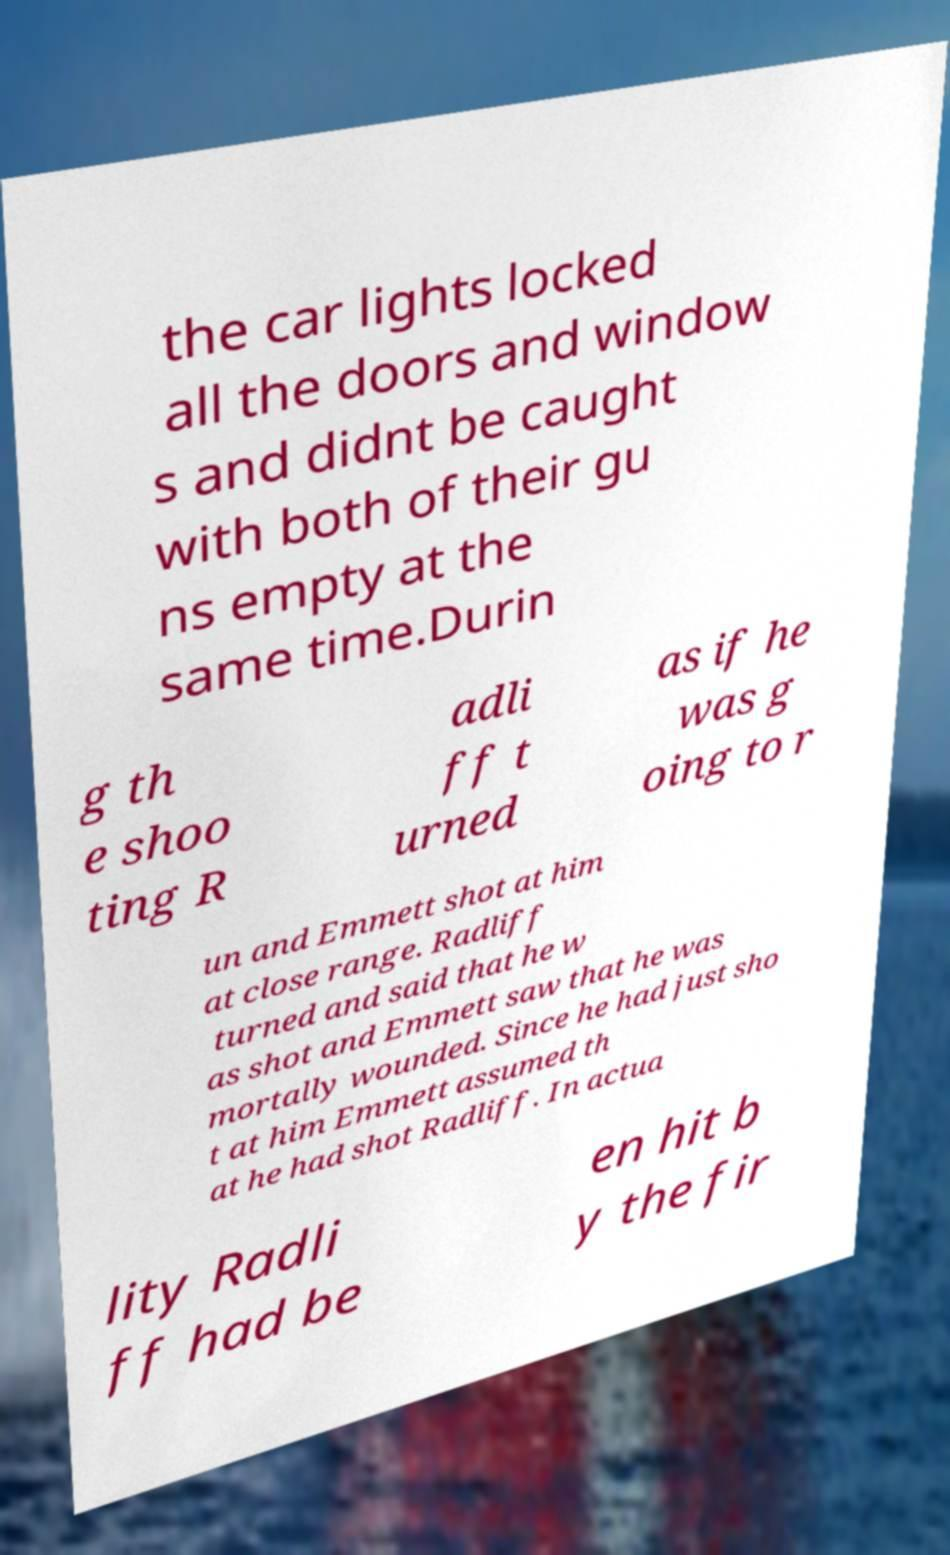For documentation purposes, I need the text within this image transcribed. Could you provide that? the car lights locked all the doors and window s and didnt be caught with both of their gu ns empty at the same time.Durin g th e shoo ting R adli ff t urned as if he was g oing to r un and Emmett shot at him at close range. Radliff turned and said that he w as shot and Emmett saw that he was mortally wounded. Since he had just sho t at him Emmett assumed th at he had shot Radliff. In actua lity Radli ff had be en hit b y the fir 